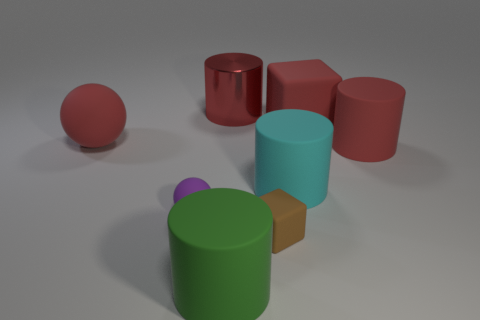There is a block that is the same color as the large rubber ball; what is its size?
Offer a terse response. Large. Are there more brown rubber objects behind the large cube than big spheres on the right side of the small purple thing?
Offer a very short reply. No. How many rubber balls are on the left side of the large red matte thing to the left of the large metallic cylinder?
Ensure brevity in your answer.  0. There is a big sphere that is the same color as the metal object; what material is it?
Keep it short and to the point. Rubber. How many other objects are the same color as the large rubber sphere?
Your answer should be very brief. 3. What color is the rubber sphere that is in front of the big red cylinder that is in front of the large red shiny cylinder?
Offer a very short reply. Purple. Is there a metallic block of the same color as the large shiny cylinder?
Make the answer very short. No. How many shiny things are either red cylinders or red balls?
Ensure brevity in your answer.  1. Is there a big brown ball made of the same material as the large cyan cylinder?
Your answer should be very brief. No. What number of blocks are behind the purple rubber object and in front of the large sphere?
Provide a short and direct response. 0. 